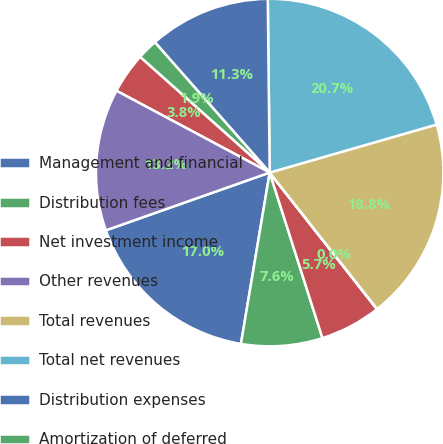Convert chart. <chart><loc_0><loc_0><loc_500><loc_500><pie_chart><fcel>Management and financial<fcel>Distribution fees<fcel>Net investment income<fcel>Other revenues<fcel>Total revenues<fcel>Total net revenues<fcel>Distribution expenses<fcel>Amortization of deferred<fcel>Interest and debt expense<fcel>General and administrative<nl><fcel>16.96%<fcel>7.56%<fcel>5.68%<fcel>0.03%<fcel>18.84%<fcel>20.72%<fcel>11.32%<fcel>1.91%<fcel>3.79%<fcel>13.2%<nl></chart> 